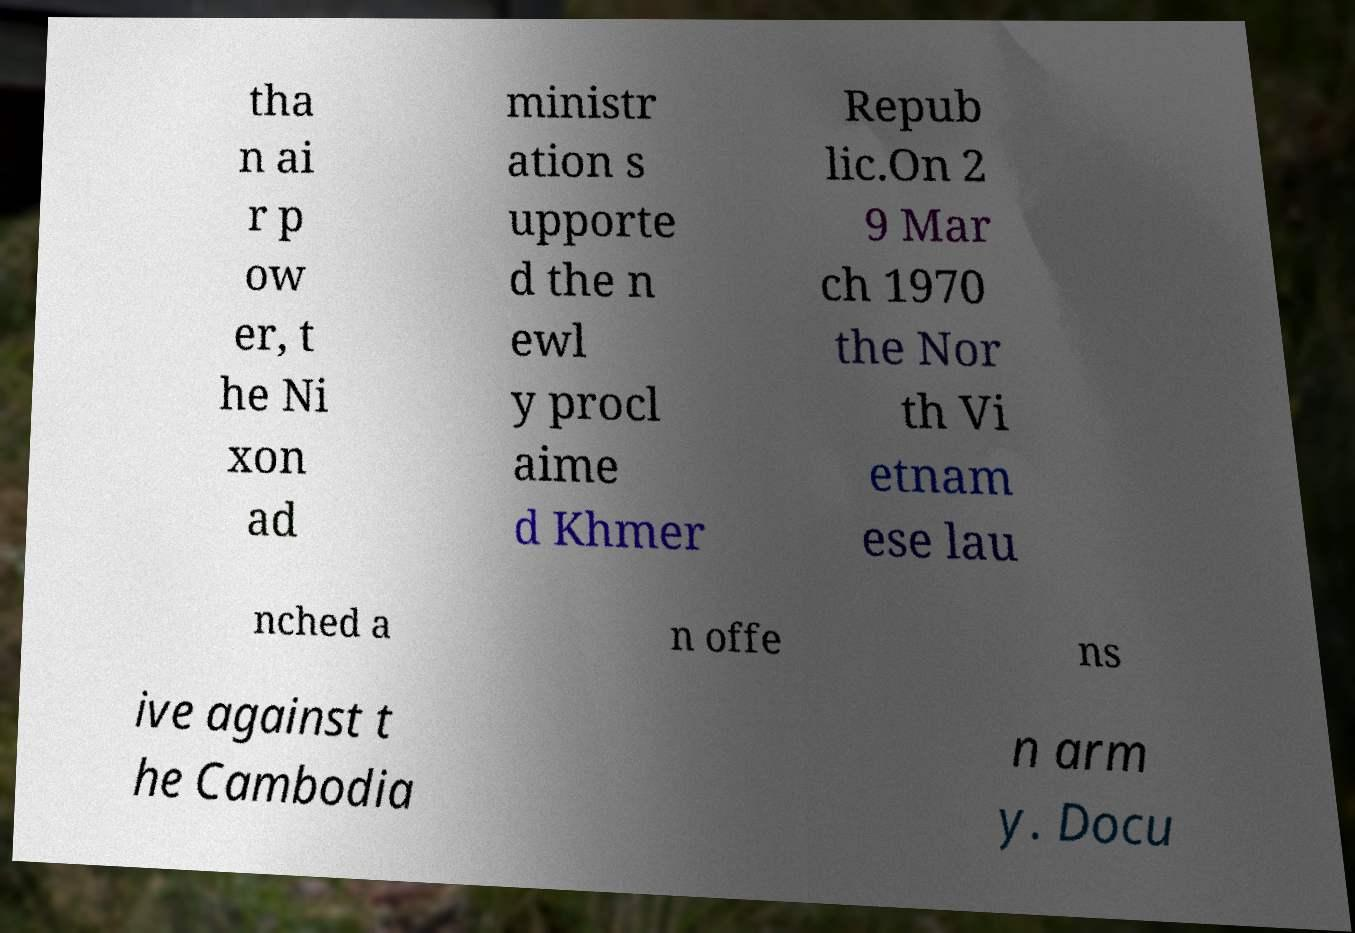There's text embedded in this image that I need extracted. Can you transcribe it verbatim? tha n ai r p ow er, t he Ni xon ad ministr ation s upporte d the n ewl y procl aime d Khmer Repub lic.On 2 9 Mar ch 1970 the Nor th Vi etnam ese lau nched a n offe ns ive against t he Cambodia n arm y. Docu 